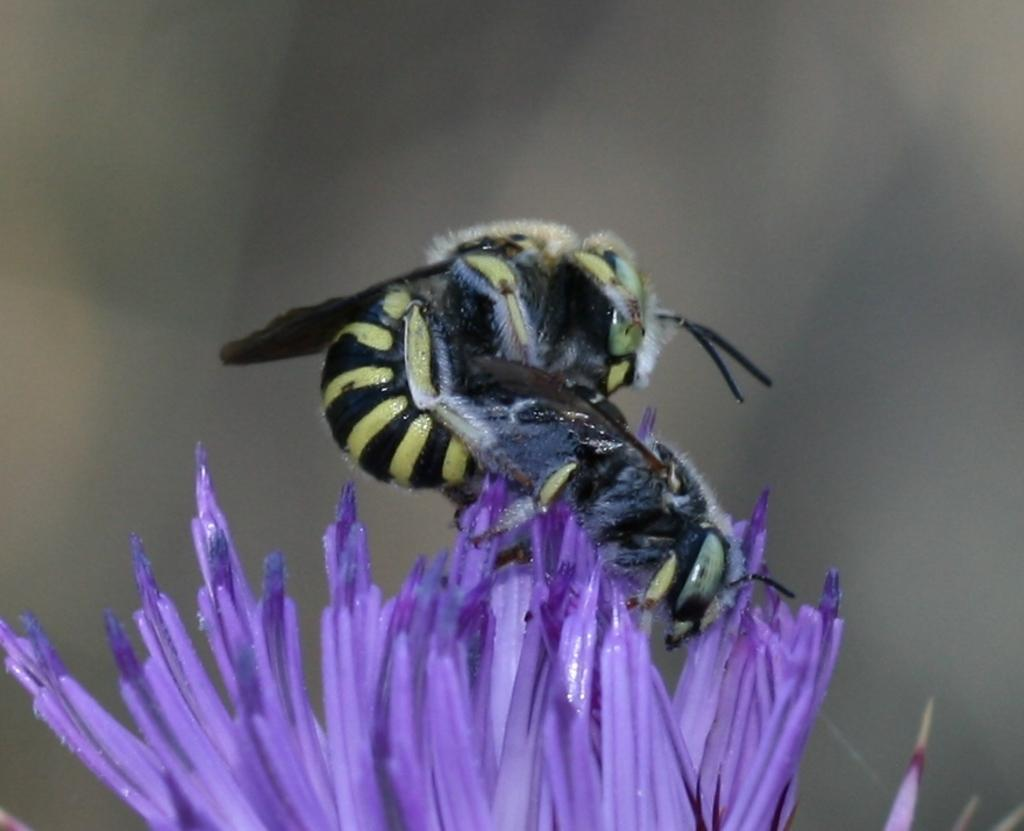What is the main subject of the image? There is an insect in the image. Where is the insect located? The insect is on a purple flower. Can you describe the background of the image? The background of the image is blurred. What type of chance game is being played in the image? There is no chance game present in the image; it features an insect on a purple flower with a blurred background. 